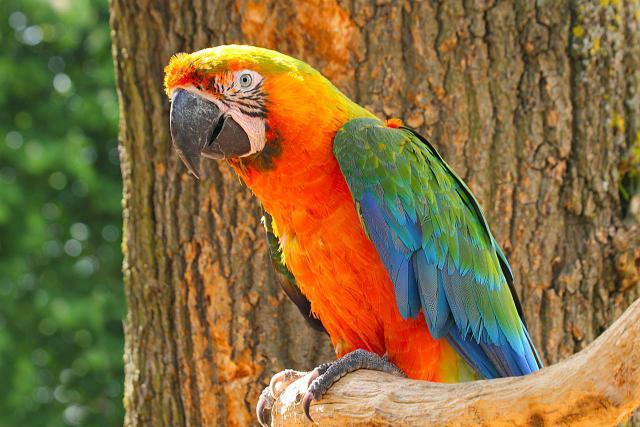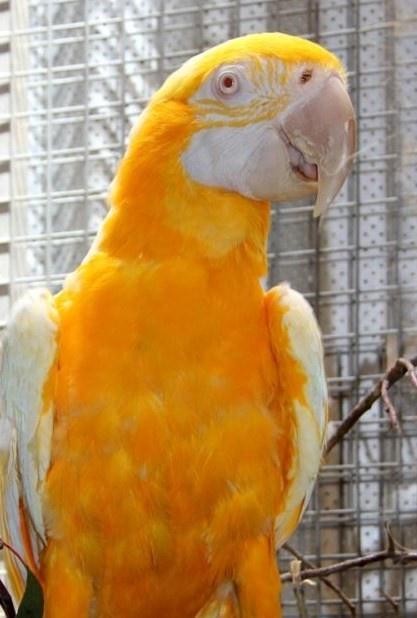The first image is the image on the left, the second image is the image on the right. Evaluate the accuracy of this statement regarding the images: "One image shows a parrot that is nearly all yellow-orange in color, without any blue.". Is it true? Answer yes or no. Yes. The first image is the image on the left, the second image is the image on the right. Evaluate the accuracy of this statement regarding the images: "Two parrots have the same eye design and beak colors.". Is it true? Answer yes or no. No. 